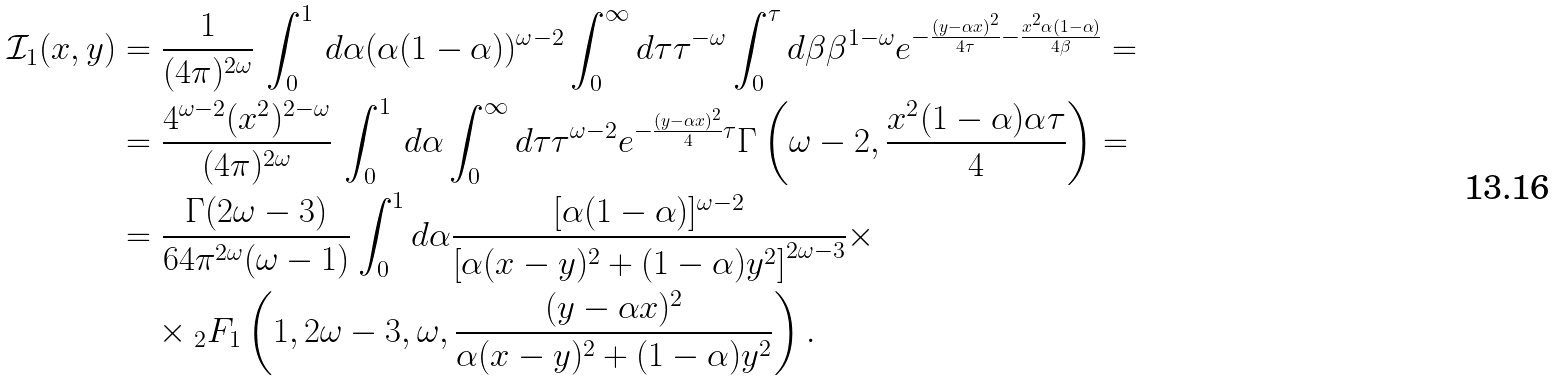<formula> <loc_0><loc_0><loc_500><loc_500>\mathcal { I } _ { 1 } ( x , y ) & = \frac { 1 } { ( 4 \pi ) ^ { 2 \omega } } \, \int _ { 0 } ^ { 1 } \, d \alpha ( \alpha ( 1 - \alpha ) ) ^ { \omega - 2 } \int _ { 0 } ^ { \infty } d \tau \tau ^ { - \omega } \int _ { 0 } ^ { \tau } d \beta \beta ^ { 1 - \omega } e ^ { - \frac { ( { y } - \alpha { x } ) ^ { 2 } } { 4 \tau } - \frac { { x } ^ { 2 } \alpha ( 1 - \alpha ) } { 4 \beta } } = \\ & = \frac { 4 ^ { \omega - 2 } ( { x } ^ { 2 } ) ^ { 2 - \omega } } { ( 4 \pi ) ^ { 2 \omega } } \, \int _ { 0 } ^ { 1 } \, d \alpha \int _ { 0 } ^ { \infty } d \tau \tau ^ { \omega - 2 } e ^ { - \frac { ( { y } - \alpha { x } ) ^ { 2 } } { 4 } \tau } \Gamma \left ( \omega - 2 , \frac { { x } ^ { 2 } ( 1 - \alpha ) \alpha \tau } { 4 } \right ) = \\ & = \frac { \Gamma ( 2 \omega - 3 ) } { 6 4 \pi ^ { 2 \omega } ( \omega - 1 ) } \int _ { 0 } ^ { 1 } d \alpha \frac { [ \alpha ( 1 - \alpha ) ] ^ { \omega - 2 } } { \left [ \alpha ( x - y ) ^ { 2 } + ( 1 - \alpha ) y ^ { 2 } \right ] ^ { 2 \omega - 3 } } \times \\ & \quad \times { _ { 2 } F _ { 1 } } \left ( 1 , 2 \omega - 3 , \omega , \frac { ( { y } - \alpha { x } ) ^ { 2 } } { \alpha ( x - y ) ^ { 2 } + ( 1 - \alpha ) y ^ { 2 } } \right ) .</formula> 